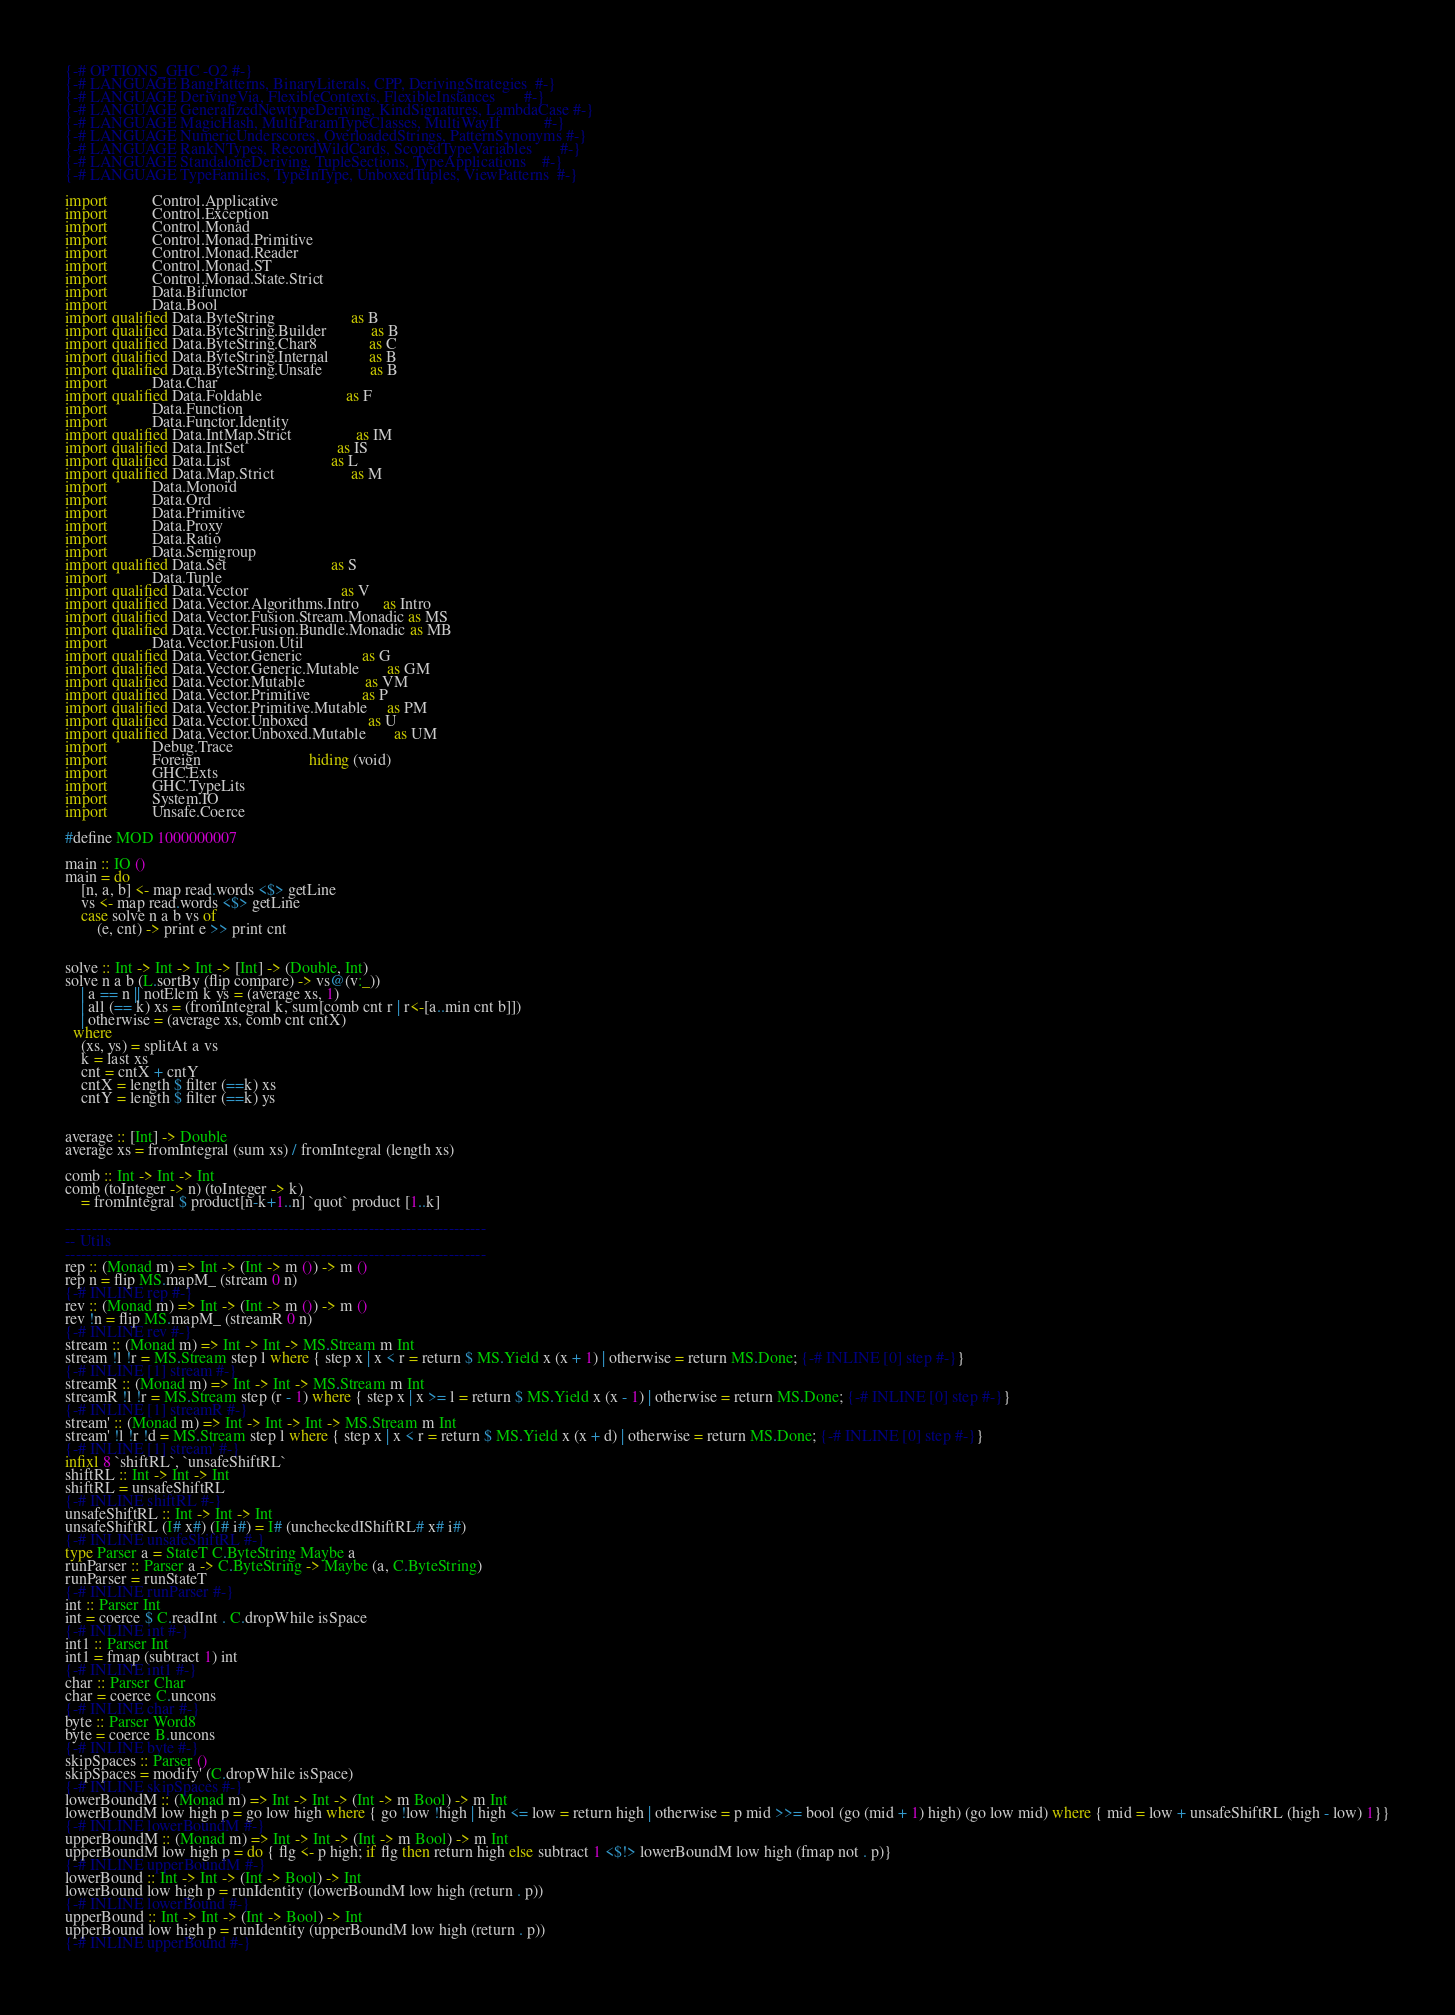<code> <loc_0><loc_0><loc_500><loc_500><_Haskell_>{-# OPTIONS_GHC -O2 #-}
{-# LANGUAGE BangPatterns, BinaryLiterals, CPP, DerivingStrategies  #-}
{-# LANGUAGE DerivingVia, FlexibleContexts, FlexibleInstances       #-}
{-# LANGUAGE GeneralizedNewtypeDeriving, KindSignatures, LambdaCase #-}
{-# LANGUAGE MagicHash, MultiParamTypeClasses, MultiWayIf           #-}
{-# LANGUAGE NumericUnderscores, OverloadedStrings, PatternSynonyms #-}
{-# LANGUAGE RankNTypes, RecordWildCards, ScopedTypeVariables       #-}
{-# LANGUAGE StandaloneDeriving, TupleSections, TypeApplications    #-}
{-# LANGUAGE TypeFamilies, TypeInType, UnboxedTuples, ViewPatterns  #-}

import           Control.Applicative
import           Control.Exception
import           Control.Monad
import           Control.Monad.Primitive
import           Control.Monad.Reader
import           Control.Monad.ST
import           Control.Monad.State.Strict
import           Data.Bifunctor
import           Data.Bool
import qualified Data.ByteString                   as B
import qualified Data.ByteString.Builder           as B
import qualified Data.ByteString.Char8             as C
import qualified Data.ByteString.Internal          as B
import qualified Data.ByteString.Unsafe            as B
import           Data.Char
import qualified Data.Foldable                     as F
import           Data.Function
import           Data.Functor.Identity
import qualified Data.IntMap.Strict                as IM
import qualified Data.IntSet                       as IS
import qualified Data.List                         as L
import qualified Data.Map.Strict                   as M
import           Data.Monoid
import           Data.Ord
import           Data.Primitive
import           Data.Proxy
import           Data.Ratio
import           Data.Semigroup
import qualified Data.Set                          as S
import           Data.Tuple
import qualified Data.Vector                       as V
import qualified Data.Vector.Algorithms.Intro      as Intro
import qualified Data.Vector.Fusion.Stream.Monadic as MS
import qualified Data.Vector.Fusion.Bundle.Monadic as MB
import           Data.Vector.Fusion.Util
import qualified Data.Vector.Generic               as G
import qualified Data.Vector.Generic.Mutable       as GM
import qualified Data.Vector.Mutable               as VM
import qualified Data.Vector.Primitive             as P
import qualified Data.Vector.Primitive.Mutable     as PM
import qualified Data.Vector.Unboxed               as U
import qualified Data.Vector.Unboxed.Mutable       as UM
import           Debug.Trace
import           Foreign                           hiding (void)
import           GHC.Exts
import           GHC.TypeLits
import           System.IO
import           Unsafe.Coerce

#define MOD 1000000007

main :: IO ()
main = do
    [n, a, b] <- map read.words <$> getLine
    vs <- map read.words <$> getLine
    case solve n a b vs of
        (e, cnt) -> print e >> print cnt


solve :: Int -> Int -> Int -> [Int] -> (Double, Int)
solve n a b (L.sortBy (flip compare) -> vs@(v:_))
    | a == n || notElem k ys = (average xs, 1)
    | all (== k) xs = (fromIntegral k, sum[comb cnt r | r<-[a..min cnt b]])
    | otherwise = (average xs, comb cnt cntX)
  where
    (xs, ys) = splitAt a vs
    k = last xs
    cnt = cntX + cntY
    cntX = length $ filter (==k) xs
    cntY = length $ filter (==k) ys


average :: [Int] -> Double
average xs = fromIntegral (sum xs) / fromIntegral (length xs)

comb :: Int -> Int -> Int
comb (toInteger -> n) (toInteger -> k)
    = fromIntegral $ product[n-k+1..n] `quot` product [1..k]

-------------------------------------------------------------------------------
-- Utils
-------------------------------------------------------------------------------
rep :: (Monad m) => Int -> (Int -> m ()) -> m ()
rep n = flip MS.mapM_ (stream 0 n)
{-# INLINE rep #-}
rev :: (Monad m) => Int -> (Int -> m ()) -> m ()
rev !n = flip MS.mapM_ (streamR 0 n)
{-# INLINE rev #-}
stream :: (Monad m) => Int -> Int -> MS.Stream m Int
stream !l !r = MS.Stream step l where { step x | x < r = return $ MS.Yield x (x + 1) | otherwise = return MS.Done; {-# INLINE [0] step #-}}
{-# INLINE [1] stream #-}
streamR :: (Monad m) => Int -> Int -> MS.Stream m Int
streamR !l !r = MS.Stream step (r - 1) where { step x | x >= l = return $ MS.Yield x (x - 1) | otherwise = return MS.Done; {-# INLINE [0] step #-}}
{-# INLINE [1] streamR #-}
stream' :: (Monad m) => Int -> Int -> Int -> MS.Stream m Int
stream' !l !r !d = MS.Stream step l where { step x | x < r = return $ MS.Yield x (x + d) | otherwise = return MS.Done; {-# INLINE [0] step #-}}
{-# INLINE [1] stream' #-}
infixl 8 `shiftRL`, `unsafeShiftRL`
shiftRL :: Int -> Int -> Int
shiftRL = unsafeShiftRL
{-# INLINE shiftRL #-}
unsafeShiftRL :: Int -> Int -> Int
unsafeShiftRL (I# x#) (I# i#) = I# (uncheckedIShiftRL# x# i#)
{-# INLINE unsafeShiftRL #-}
type Parser a = StateT C.ByteString Maybe a
runParser :: Parser a -> C.ByteString -> Maybe (a, C.ByteString)
runParser = runStateT
{-# INLINE runParser #-}
int :: Parser Int
int = coerce $ C.readInt . C.dropWhile isSpace
{-# INLINE int #-}
int1 :: Parser Int
int1 = fmap (subtract 1) int
{-# INLINE int1 #-}
char :: Parser Char
char = coerce C.uncons
{-# INLINE char #-}
byte :: Parser Word8
byte = coerce B.uncons
{-# INLINE byte #-}
skipSpaces :: Parser ()
skipSpaces = modify' (C.dropWhile isSpace)
{-# INLINE skipSpaces #-}
lowerBoundM :: (Monad m) => Int -> Int -> (Int -> m Bool) -> m Int
lowerBoundM low high p = go low high where { go !low !high | high <= low = return high | otherwise = p mid >>= bool (go (mid + 1) high) (go low mid) where { mid = low + unsafeShiftRL (high - low) 1}}
{-# INLINE lowerBoundM #-}
upperBoundM :: (Monad m) => Int -> Int -> (Int -> m Bool) -> m Int
upperBoundM low high p = do { flg <- p high; if flg then return high else subtract 1 <$!> lowerBoundM low high (fmap not . p)}
{-# INLINE upperBoundM #-}
lowerBound :: Int -> Int -> (Int -> Bool) -> Int
lowerBound low high p = runIdentity (lowerBoundM low high (return . p))
{-# INLINE lowerBound #-}
upperBound :: Int -> Int -> (Int -> Bool) -> Int
upperBound low high p = runIdentity (upperBoundM low high (return . p))
{-# INLINE upperBound #-}
</code> 